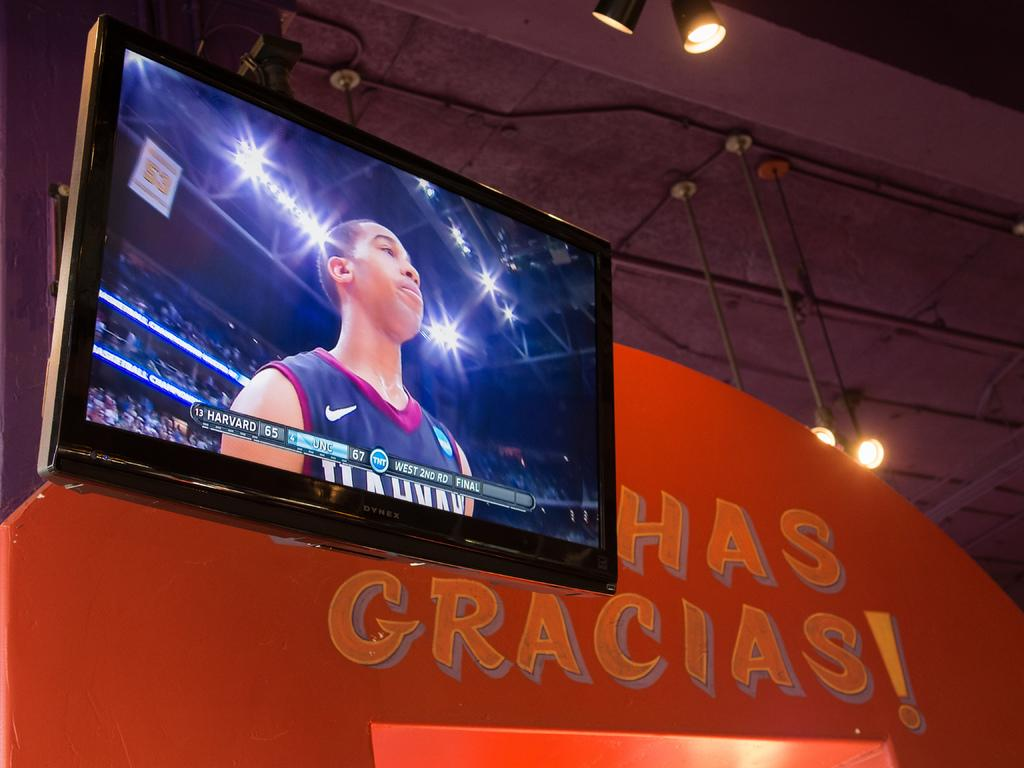<image>
Provide a brief description of the given image. a TNT broadcast that is on the television 